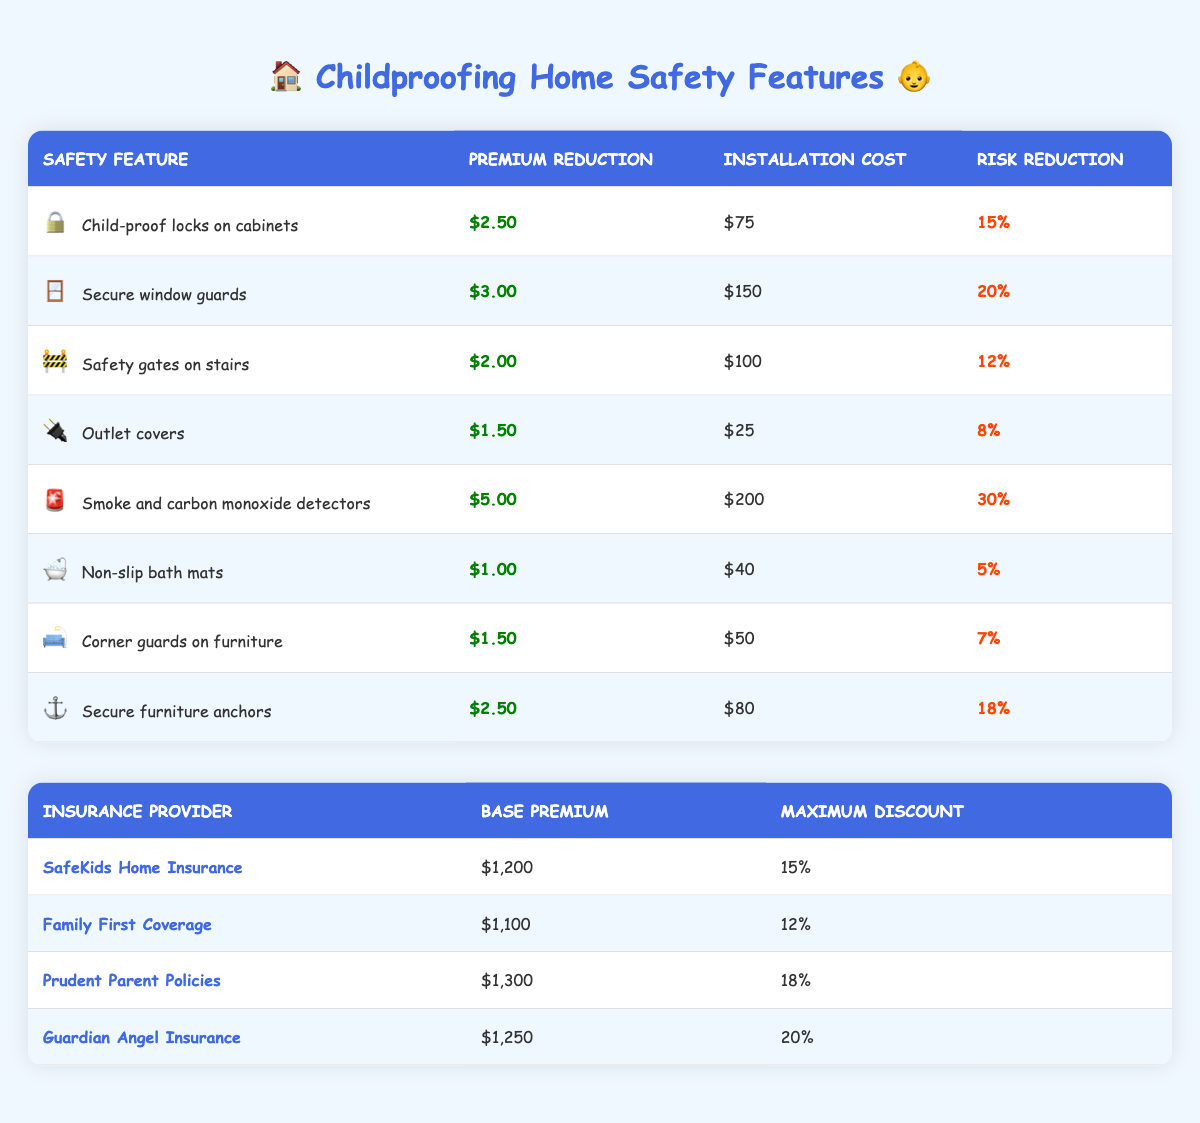What is the maximum discount offered by Guardian Angel Insurance? The table shows the maximum discount for each insurance provider. For Guardian Angel Insurance, the specified maximum discount is clearly stated in the table, which is 20%.
Answer: 20% What is the installation cost of smoke and carbon monoxide detectors? Looking at the safety features table, the installation cost for smoke and carbon monoxide detectors is listed directly, which is $200.
Answer: $200 What is the total premium reduction if I install child-proof locks on cabinets and secure window guards? The premium reduction for installing child-proof locks on cabinets is $2.50 and for secure window guards, it is $3.00. Adding these two amounts together gives $2.50 + $3.00 = $5.50 as the total premium reduction.
Answer: $5.50 Does securing furniture anchors reduce the premium by more than $2.00? The premium reduction for secure furniture anchors is listed at $2.50, which is indeed more than $2.00, confirming that it does reduce the premium sufficiently.
Answer: Yes What is the average risk reduction percentage for all the safety features listed? To find the average risk reduction percentage, we first convert all percentages from the table into numbers: 15, 20, 12, 8, 30, 5, 7, and 18. Adding these gives 115 (15+20+12+8+30+5+7+18). There are 8 features, so we divide the sum by the number of features: 115/8 = 14.375. Thus, the average risk reduction percentage is 14.375%.
Answer: 14.375% What is the lowest premium reduction available among the safety features? By reviewing the premium reduction amounts for each feature specifically, we see that outlet covers provide the least reduction at $1.50, making it the lowest among the options listed.
Answer: $1.50 If I install safety gates on stairs, what would my new base insurance premium be with Family First Coverage? The base premium for Family First Coverage is $1,100, and installing safety gates on stairs would reduce the premium by $2.00. Therefore, the new insurance premium would be $1,100 - $2.00 = $1,098.
Answer: $1,098 Is the installation cost of non-slip bath mats less than the premium reduction from outlet covers? The installation cost for non-slip bath mats is $40 while the premium reduction for outlet covers is $1.50. Since $40 is greater than $1.50, the answer is no.
Answer: No What combined risk reduction percentage do I achieve if I install all safety features? The combined risk reduction would be calculated by adding together all individual risk reduction percentages from the features: 15 + 20 + 12 + 8 + 30 + 5 + 7 + 18 = 115%. The total risk reduction percentage for installing all safety features amounts to 115%.
Answer: 115% 